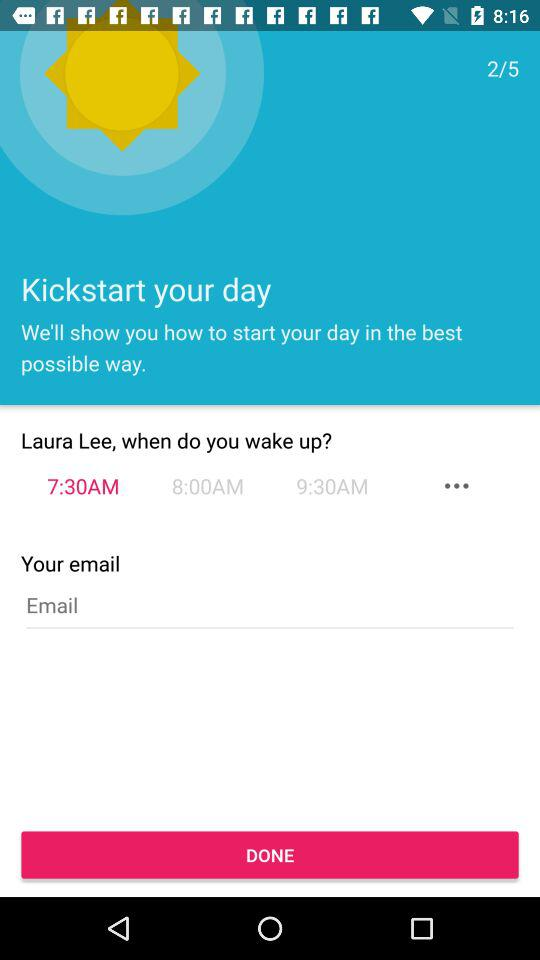What is the user name? The user name is Laura Lee. 